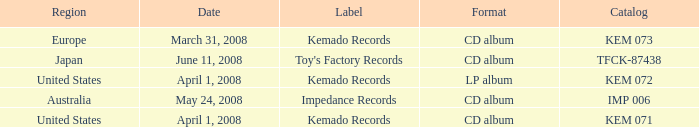Which Format has a Date of may 24, 2008? CD album. 